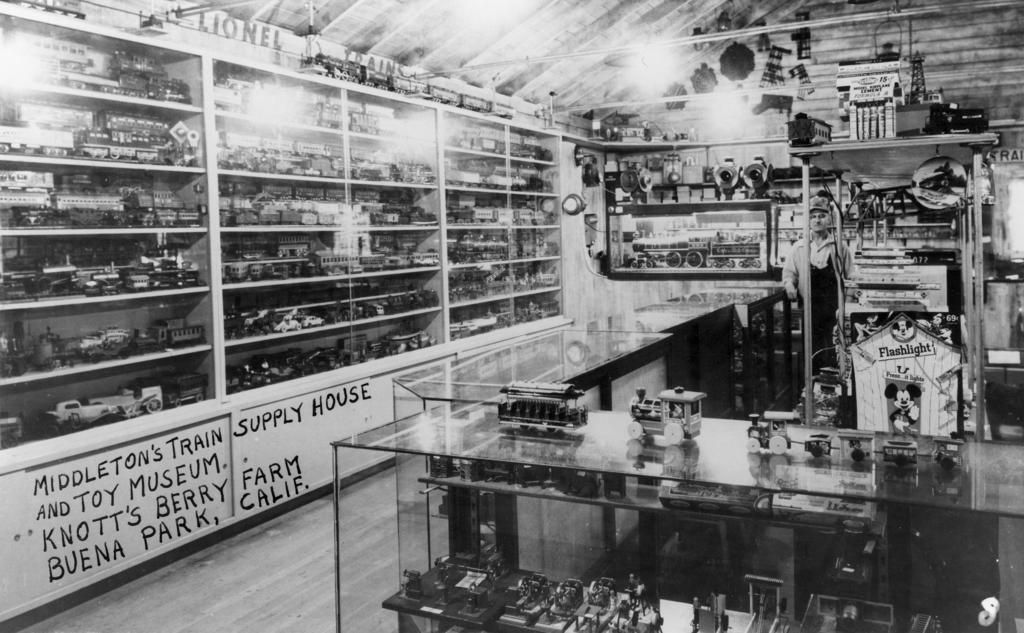<image>
Create a compact narrative representing the image presented. Shelves with multiple items along with what seems to be model trains and other items around the room 